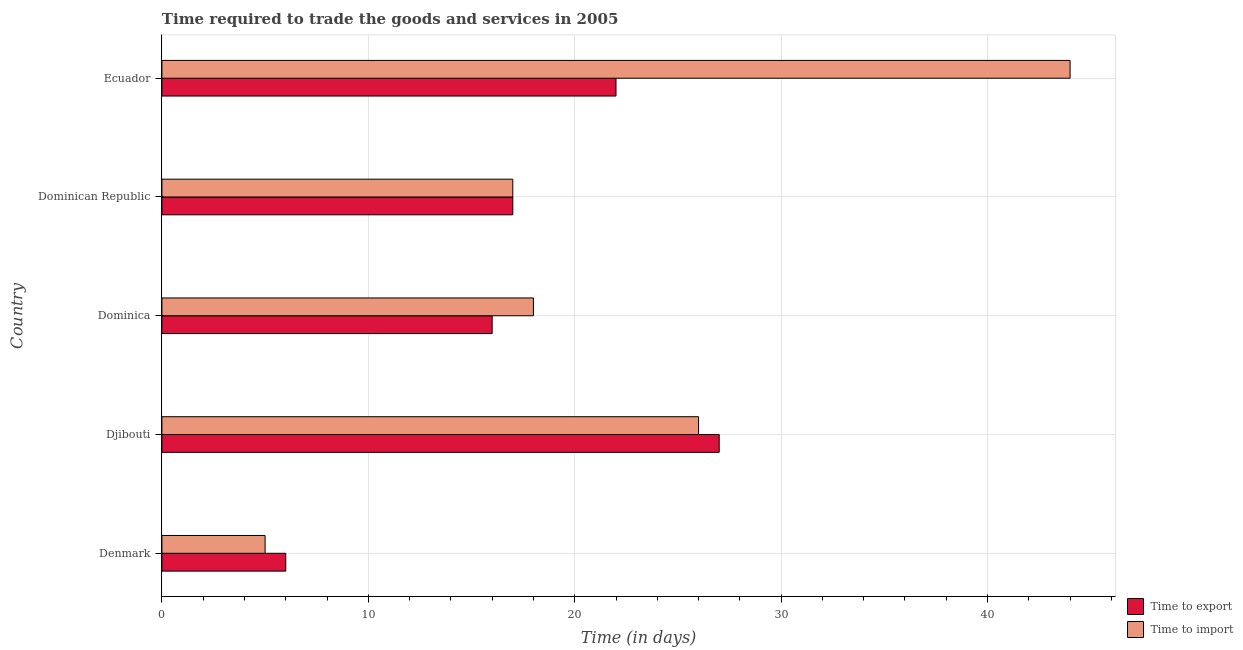Are the number of bars per tick equal to the number of legend labels?
Make the answer very short. Yes. Are the number of bars on each tick of the Y-axis equal?
Give a very brief answer. Yes. How many bars are there on the 2nd tick from the top?
Provide a short and direct response. 2. What is the label of the 4th group of bars from the top?
Provide a succinct answer. Djibouti. Across all countries, what is the minimum time to import?
Give a very brief answer. 5. In which country was the time to import maximum?
Give a very brief answer. Ecuador. In which country was the time to import minimum?
Ensure brevity in your answer.  Denmark. What is the difference between the time to export in Denmark and that in Dominica?
Offer a very short reply. -10. What is the difference between the time to import in Ecuador and the time to export in Dominica?
Give a very brief answer. 28. What is the average time to export per country?
Offer a terse response. 17.6. In how many countries, is the time to export greater than 38 days?
Offer a terse response. 0. What is the ratio of the time to export in Denmark to that in Ecuador?
Offer a very short reply. 0.27. Is the time to import in Denmark less than that in Ecuador?
Your answer should be compact. Yes. In how many countries, is the time to import greater than the average time to import taken over all countries?
Your answer should be compact. 2. What does the 2nd bar from the top in Denmark represents?
Keep it short and to the point. Time to export. What does the 2nd bar from the bottom in Djibouti represents?
Make the answer very short. Time to import. Are all the bars in the graph horizontal?
Your response must be concise. Yes. How many countries are there in the graph?
Your answer should be very brief. 5. What is the difference between two consecutive major ticks on the X-axis?
Give a very brief answer. 10. Where does the legend appear in the graph?
Make the answer very short. Bottom right. What is the title of the graph?
Provide a succinct answer. Time required to trade the goods and services in 2005. What is the label or title of the X-axis?
Your response must be concise. Time (in days). What is the label or title of the Y-axis?
Your response must be concise. Country. What is the Time (in days) in Time to export in Denmark?
Give a very brief answer. 6. What is the Time (in days) in Time to export in Dominica?
Make the answer very short. 16. What is the Time (in days) of Time to export in Dominican Republic?
Your answer should be compact. 17. What is the Time (in days) of Time to import in Dominican Republic?
Make the answer very short. 17. What is the Time (in days) of Time to import in Ecuador?
Ensure brevity in your answer.  44. Across all countries, what is the maximum Time (in days) in Time to export?
Your answer should be compact. 27. Across all countries, what is the maximum Time (in days) in Time to import?
Your answer should be compact. 44. Across all countries, what is the minimum Time (in days) in Time to export?
Give a very brief answer. 6. Across all countries, what is the minimum Time (in days) in Time to import?
Provide a short and direct response. 5. What is the total Time (in days) in Time to export in the graph?
Ensure brevity in your answer.  88. What is the total Time (in days) in Time to import in the graph?
Provide a succinct answer. 110. What is the difference between the Time (in days) of Time to export in Denmark and that in Djibouti?
Keep it short and to the point. -21. What is the difference between the Time (in days) in Time to import in Denmark and that in Djibouti?
Make the answer very short. -21. What is the difference between the Time (in days) of Time to import in Denmark and that in Dominican Republic?
Your answer should be compact. -12. What is the difference between the Time (in days) in Time to export in Denmark and that in Ecuador?
Provide a short and direct response. -16. What is the difference between the Time (in days) in Time to import in Denmark and that in Ecuador?
Make the answer very short. -39. What is the difference between the Time (in days) in Time to import in Djibouti and that in Dominican Republic?
Your answer should be very brief. 9. What is the difference between the Time (in days) in Time to export in Djibouti and that in Ecuador?
Ensure brevity in your answer.  5. What is the difference between the Time (in days) of Time to import in Dominica and that in Dominican Republic?
Provide a short and direct response. 1. What is the difference between the Time (in days) of Time to export in Dominica and that in Ecuador?
Ensure brevity in your answer.  -6. What is the difference between the Time (in days) of Time to import in Dominican Republic and that in Ecuador?
Ensure brevity in your answer.  -27. What is the difference between the Time (in days) in Time to export in Denmark and the Time (in days) in Time to import in Dominica?
Your answer should be compact. -12. What is the difference between the Time (in days) of Time to export in Denmark and the Time (in days) of Time to import in Dominican Republic?
Provide a succinct answer. -11. What is the difference between the Time (in days) of Time to export in Denmark and the Time (in days) of Time to import in Ecuador?
Ensure brevity in your answer.  -38. What is the difference between the Time (in days) of Time to export in Djibouti and the Time (in days) of Time to import in Dominica?
Provide a short and direct response. 9. What is the difference between the Time (in days) in Time to export in Djibouti and the Time (in days) in Time to import in Ecuador?
Make the answer very short. -17. What is the difference between the Time (in days) of Time to export in Dominica and the Time (in days) of Time to import in Ecuador?
Your response must be concise. -28. What is the difference between the Time (in days) in Time to export and Time (in days) in Time to import in Denmark?
Offer a terse response. 1. What is the difference between the Time (in days) of Time to export and Time (in days) of Time to import in Dominica?
Offer a terse response. -2. What is the difference between the Time (in days) of Time to export and Time (in days) of Time to import in Dominican Republic?
Your answer should be very brief. 0. What is the difference between the Time (in days) in Time to export and Time (in days) in Time to import in Ecuador?
Keep it short and to the point. -22. What is the ratio of the Time (in days) in Time to export in Denmark to that in Djibouti?
Your answer should be very brief. 0.22. What is the ratio of the Time (in days) in Time to import in Denmark to that in Djibouti?
Give a very brief answer. 0.19. What is the ratio of the Time (in days) of Time to export in Denmark to that in Dominica?
Provide a succinct answer. 0.38. What is the ratio of the Time (in days) in Time to import in Denmark to that in Dominica?
Your response must be concise. 0.28. What is the ratio of the Time (in days) in Time to export in Denmark to that in Dominican Republic?
Make the answer very short. 0.35. What is the ratio of the Time (in days) of Time to import in Denmark to that in Dominican Republic?
Ensure brevity in your answer.  0.29. What is the ratio of the Time (in days) in Time to export in Denmark to that in Ecuador?
Provide a short and direct response. 0.27. What is the ratio of the Time (in days) in Time to import in Denmark to that in Ecuador?
Your answer should be very brief. 0.11. What is the ratio of the Time (in days) of Time to export in Djibouti to that in Dominica?
Keep it short and to the point. 1.69. What is the ratio of the Time (in days) in Time to import in Djibouti to that in Dominica?
Make the answer very short. 1.44. What is the ratio of the Time (in days) in Time to export in Djibouti to that in Dominican Republic?
Keep it short and to the point. 1.59. What is the ratio of the Time (in days) of Time to import in Djibouti to that in Dominican Republic?
Give a very brief answer. 1.53. What is the ratio of the Time (in days) in Time to export in Djibouti to that in Ecuador?
Keep it short and to the point. 1.23. What is the ratio of the Time (in days) in Time to import in Djibouti to that in Ecuador?
Provide a short and direct response. 0.59. What is the ratio of the Time (in days) of Time to import in Dominica to that in Dominican Republic?
Ensure brevity in your answer.  1.06. What is the ratio of the Time (in days) of Time to export in Dominica to that in Ecuador?
Keep it short and to the point. 0.73. What is the ratio of the Time (in days) of Time to import in Dominica to that in Ecuador?
Give a very brief answer. 0.41. What is the ratio of the Time (in days) in Time to export in Dominican Republic to that in Ecuador?
Provide a short and direct response. 0.77. What is the ratio of the Time (in days) in Time to import in Dominican Republic to that in Ecuador?
Keep it short and to the point. 0.39. What is the difference between the highest and the second highest Time (in days) of Time to export?
Your response must be concise. 5. 